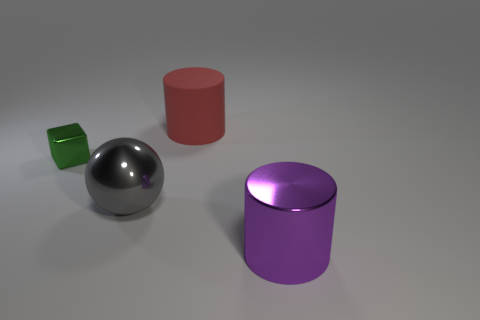There is a gray sphere; what number of small green things are on the left side of it?
Make the answer very short. 1. There is a large cylinder that is on the left side of the big shiny object that is to the right of the gray metallic sphere; are there any big rubber cylinders that are on the right side of it?
Ensure brevity in your answer.  No. Does the gray object have the same size as the metal cylinder?
Your answer should be compact. Yes. Are there an equal number of objects left of the tiny green thing and tiny green objects right of the big ball?
Your response must be concise. Yes. There is a metal thing that is on the right side of the gray metal sphere; what is its shape?
Offer a very short reply. Cylinder. There is a purple shiny object that is the same size as the sphere; what shape is it?
Offer a terse response. Cylinder. What color is the cylinder that is left of the large cylinder in front of the cylinder that is left of the purple object?
Ensure brevity in your answer.  Red. Does the large purple shiny object have the same shape as the large matte object?
Make the answer very short. Yes. Are there an equal number of tiny metal cubes that are in front of the purple metallic object and cyan matte blocks?
Give a very brief answer. Yes. How many other objects are there of the same material as the tiny cube?
Provide a succinct answer. 2. 